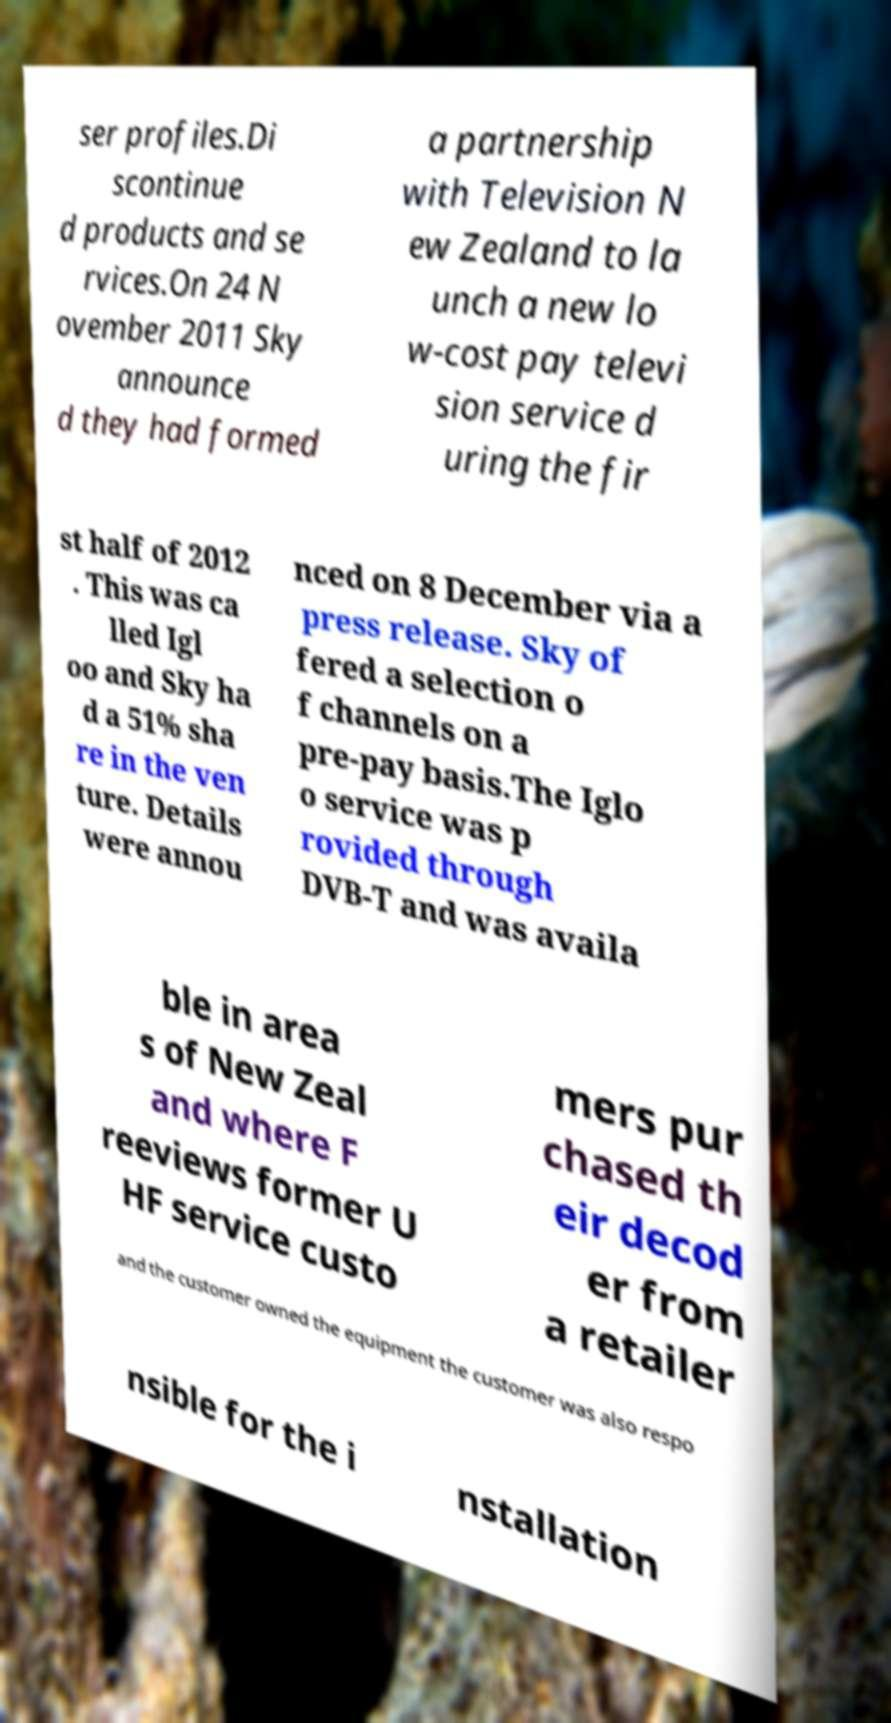Please identify and transcribe the text found in this image. ser profiles.Di scontinue d products and se rvices.On 24 N ovember 2011 Sky announce d they had formed a partnership with Television N ew Zealand to la unch a new lo w-cost pay televi sion service d uring the fir st half of 2012 . This was ca lled Igl oo and Sky ha d a 51% sha re in the ven ture. Details were annou nced on 8 December via a press release. Sky of fered a selection o f channels on a pre-pay basis.The Iglo o service was p rovided through DVB-T and was availa ble in area s of New Zeal and where F reeviews former U HF service custo mers pur chased th eir decod er from a retailer and the customer owned the equipment the customer was also respo nsible for the i nstallation 